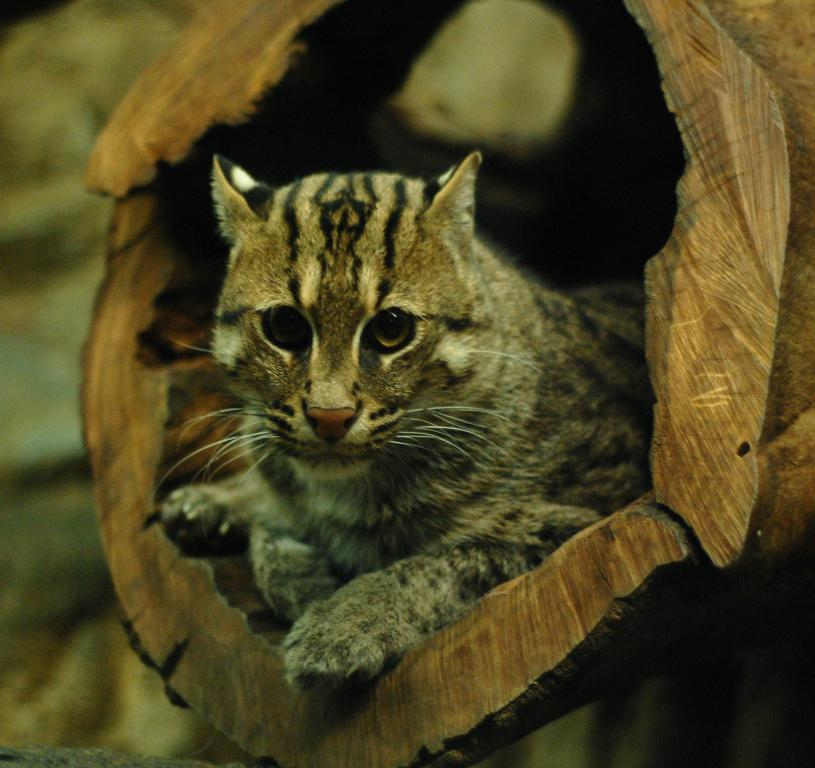What type of animal is in the image? There is a cat in the image. What colors can be seen on the cat? The cat has brown and black colors. What is the cat doing in the image? The cat is laying on some object. What type of creator is depicted in the image? There is no creator depicted in the image; it features a cat laying on an object. Can you tell me how many gravestones are present in the image? There are no gravestones or cemetery elements present in the image; it features a cat laying on an object. 